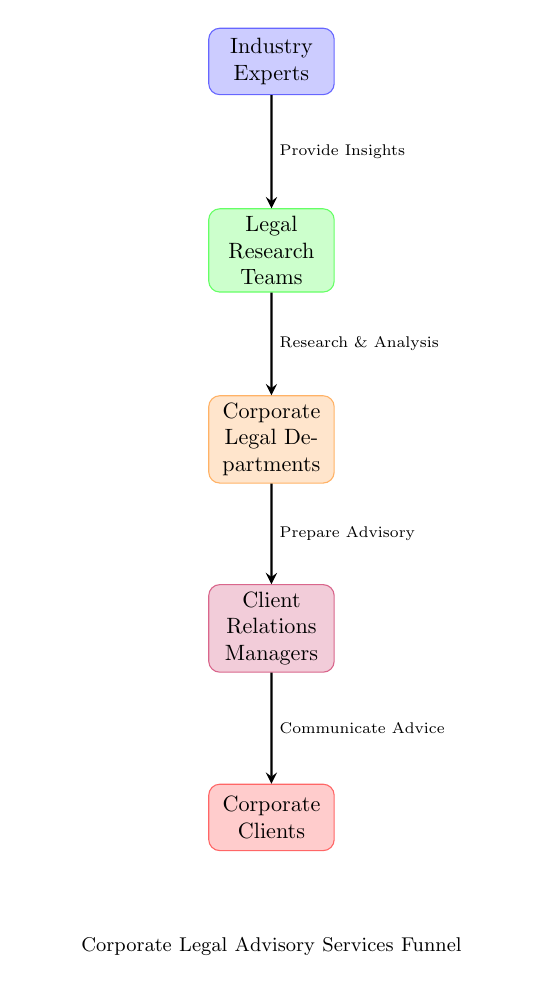What is the first node in the diagram? The first node listed in the diagram is "Industry Experts," which is positioned at the top of the flow.
Answer: Industry Experts How many nodes are there in total? The diagram depicts a total of five nodes, beginning from "Industry Experts" down to "Corporate Clients."
Answer: 5 What action is taken by the Legal Research Teams? According to the diagram, the Legal Research Teams perform "Research & Analysis" as their action, facilitating the flow of information.
Answer: Research & Analysis What is the role of Client Relations Managers? The role of Client Relations Managers, as indicated in the diagram, is to "Communicate Advice" to the Corporate Clients.
Answer: Communicate Advice Which node provides insights to the next stage? The "Industry Experts" node provides insights to the following node, which is the "Legal Research Teams."
Answer: Industry Experts How does the flow of the diagram progress from the Legal Research Teams? The flow progresses from Legal Research Teams to Corporate Legal Departments through the action of "Research & Analysis," establishing a link between these two nodes.
Answer: Research & Analysis Which stakeholder is at the end of the funnel? The final stakeholder in the funnel, as depicted in the diagram, is "Corporate Clients," who receive the communicated advice.
Answer: Corporate Clients What is the connection between Corporate Legal Departments and Client Relations Managers? The connection is that Corporate Legal Departments "Prepare Advisory" for the Client Relations Managers, establishing a direct informational link between these two nodes.
Answer: Prepare Advisory How many actions are described in the diagram? The diagram illustrates four specific actions that connect the five nodes, detailing the flow of legal advice dissemination.
Answer: 4 